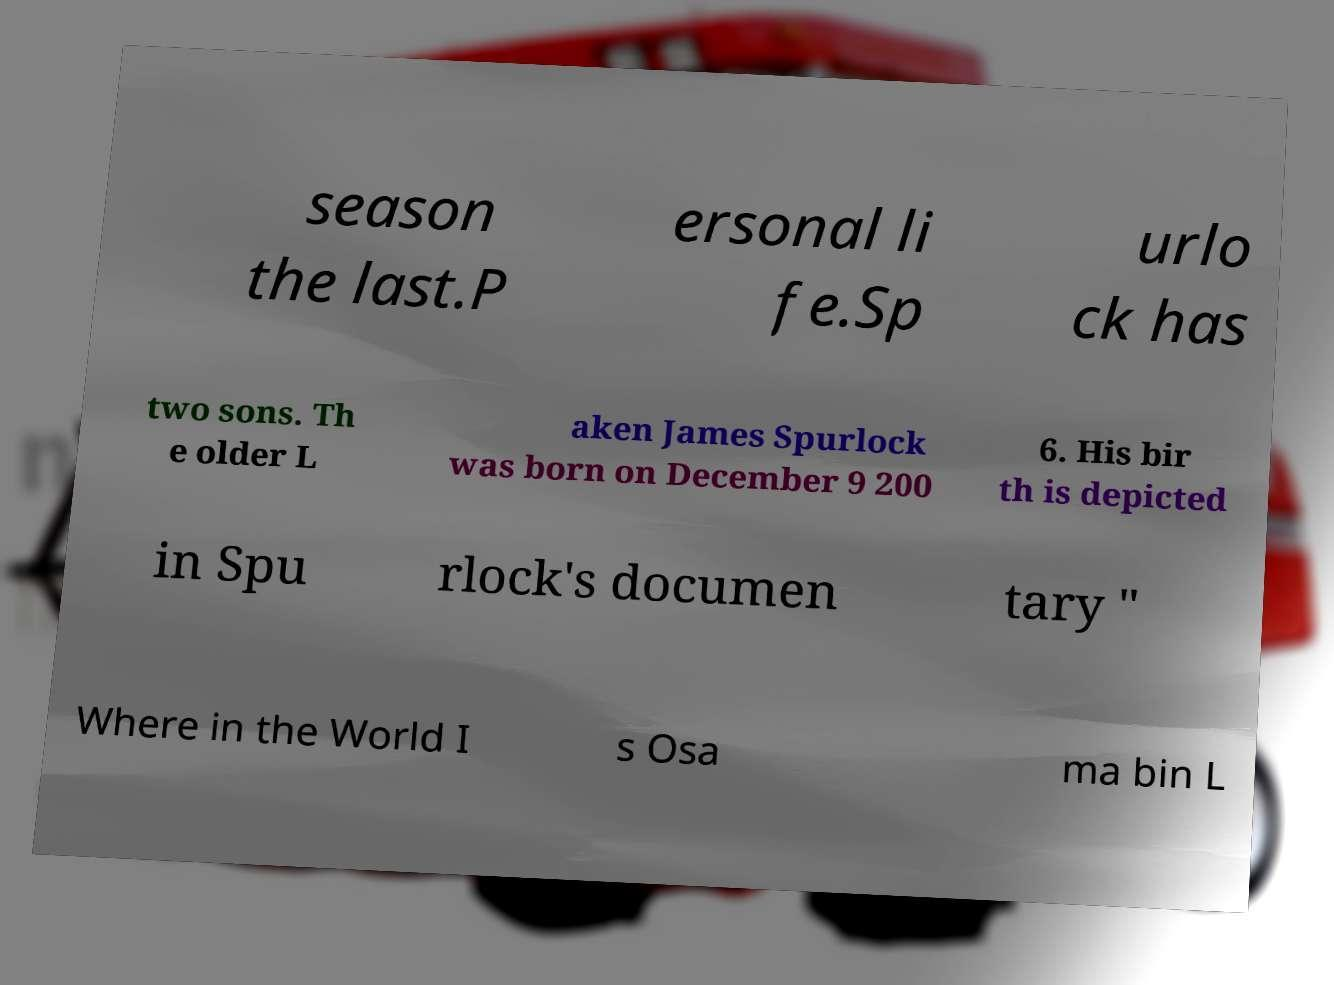Can you read and provide the text displayed in the image?This photo seems to have some interesting text. Can you extract and type it out for me? season the last.P ersonal li fe.Sp urlo ck has two sons. Th e older L aken James Spurlock was born on December 9 200 6. His bir th is depicted in Spu rlock's documen tary " Where in the World I s Osa ma bin L 